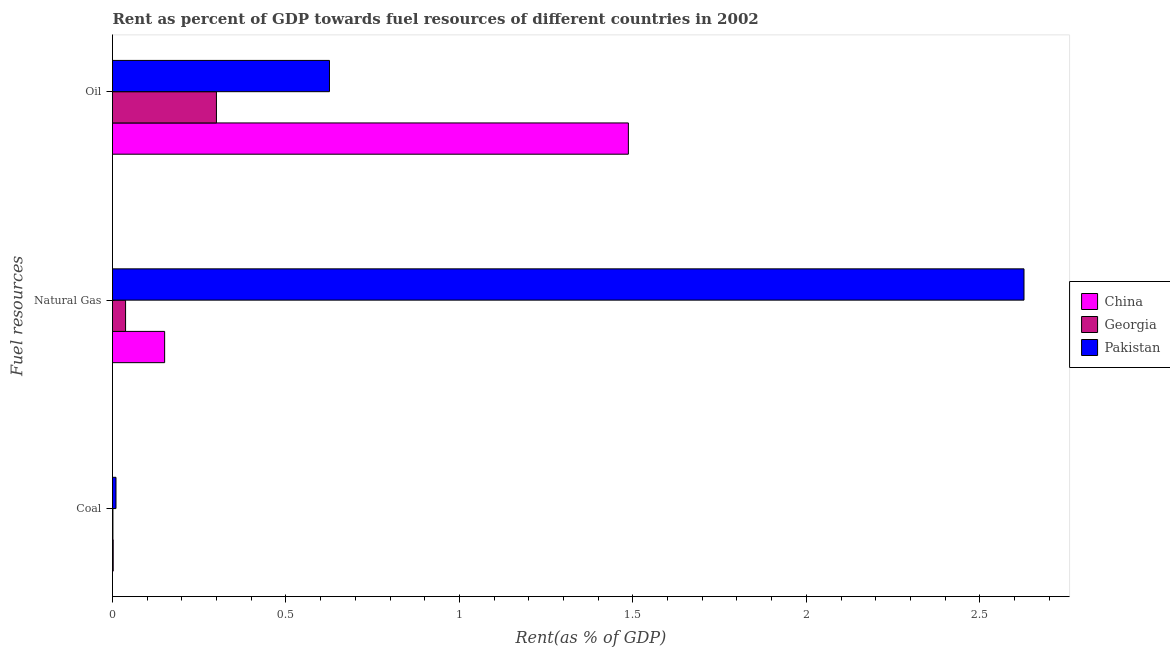How many groups of bars are there?
Your answer should be very brief. 3. Are the number of bars per tick equal to the number of legend labels?
Provide a short and direct response. Yes. Are the number of bars on each tick of the Y-axis equal?
Your answer should be very brief. Yes. How many bars are there on the 3rd tick from the top?
Your answer should be very brief. 3. What is the label of the 2nd group of bars from the top?
Offer a terse response. Natural Gas. What is the rent towards oil in Pakistan?
Offer a terse response. 0.63. Across all countries, what is the maximum rent towards natural gas?
Your response must be concise. 2.63. Across all countries, what is the minimum rent towards coal?
Provide a short and direct response. 0. In which country was the rent towards coal minimum?
Your response must be concise. Georgia. What is the total rent towards natural gas in the graph?
Offer a terse response. 2.82. What is the difference between the rent towards oil in Pakistan and that in Georgia?
Provide a short and direct response. 0.33. What is the difference between the rent towards natural gas in Georgia and the rent towards coal in China?
Offer a very short reply. 0.04. What is the average rent towards natural gas per country?
Keep it short and to the point. 0.94. What is the difference between the rent towards natural gas and rent towards coal in China?
Offer a very short reply. 0.15. In how many countries, is the rent towards oil greater than 1.4 %?
Offer a very short reply. 1. What is the ratio of the rent towards oil in Pakistan to that in China?
Give a very brief answer. 0.42. What is the difference between the highest and the second highest rent towards natural gas?
Your response must be concise. 2.48. What is the difference between the highest and the lowest rent towards oil?
Make the answer very short. 1.19. In how many countries, is the rent towards coal greater than the average rent towards coal taken over all countries?
Make the answer very short. 1. What does the 2nd bar from the bottom in Oil represents?
Your answer should be compact. Georgia. How many bars are there?
Provide a succinct answer. 9. What is the difference between two consecutive major ticks on the X-axis?
Your answer should be compact. 0.5. Where does the legend appear in the graph?
Offer a very short reply. Center right. What is the title of the graph?
Keep it short and to the point. Rent as percent of GDP towards fuel resources of different countries in 2002. What is the label or title of the X-axis?
Ensure brevity in your answer.  Rent(as % of GDP). What is the label or title of the Y-axis?
Ensure brevity in your answer.  Fuel resources. What is the Rent(as % of GDP) in China in Coal?
Provide a short and direct response. 0. What is the Rent(as % of GDP) of Georgia in Coal?
Give a very brief answer. 0. What is the Rent(as % of GDP) of Pakistan in Coal?
Offer a very short reply. 0.01. What is the Rent(as % of GDP) in China in Natural Gas?
Offer a very short reply. 0.15. What is the Rent(as % of GDP) of Georgia in Natural Gas?
Your response must be concise. 0.04. What is the Rent(as % of GDP) of Pakistan in Natural Gas?
Provide a short and direct response. 2.63. What is the Rent(as % of GDP) of China in Oil?
Your answer should be very brief. 1.49. What is the Rent(as % of GDP) of Georgia in Oil?
Make the answer very short. 0.3. What is the Rent(as % of GDP) of Pakistan in Oil?
Keep it short and to the point. 0.63. Across all Fuel resources, what is the maximum Rent(as % of GDP) of China?
Make the answer very short. 1.49. Across all Fuel resources, what is the maximum Rent(as % of GDP) in Georgia?
Your answer should be compact. 0.3. Across all Fuel resources, what is the maximum Rent(as % of GDP) in Pakistan?
Your answer should be very brief. 2.63. Across all Fuel resources, what is the minimum Rent(as % of GDP) in China?
Your answer should be compact. 0. Across all Fuel resources, what is the minimum Rent(as % of GDP) in Georgia?
Provide a succinct answer. 0. Across all Fuel resources, what is the minimum Rent(as % of GDP) in Pakistan?
Offer a very short reply. 0.01. What is the total Rent(as % of GDP) in China in the graph?
Provide a succinct answer. 1.64. What is the total Rent(as % of GDP) of Georgia in the graph?
Offer a very short reply. 0.34. What is the total Rent(as % of GDP) of Pakistan in the graph?
Offer a very short reply. 3.26. What is the difference between the Rent(as % of GDP) in China in Coal and that in Natural Gas?
Your answer should be compact. -0.15. What is the difference between the Rent(as % of GDP) of Georgia in Coal and that in Natural Gas?
Give a very brief answer. -0.04. What is the difference between the Rent(as % of GDP) in Pakistan in Coal and that in Natural Gas?
Ensure brevity in your answer.  -2.62. What is the difference between the Rent(as % of GDP) in China in Coal and that in Oil?
Offer a very short reply. -1.48. What is the difference between the Rent(as % of GDP) of Georgia in Coal and that in Oil?
Offer a very short reply. -0.3. What is the difference between the Rent(as % of GDP) of Pakistan in Coal and that in Oil?
Your answer should be compact. -0.62. What is the difference between the Rent(as % of GDP) in China in Natural Gas and that in Oil?
Give a very brief answer. -1.34. What is the difference between the Rent(as % of GDP) of Georgia in Natural Gas and that in Oil?
Keep it short and to the point. -0.26. What is the difference between the Rent(as % of GDP) in Pakistan in Natural Gas and that in Oil?
Ensure brevity in your answer.  2. What is the difference between the Rent(as % of GDP) in China in Coal and the Rent(as % of GDP) in Georgia in Natural Gas?
Your response must be concise. -0.04. What is the difference between the Rent(as % of GDP) in China in Coal and the Rent(as % of GDP) in Pakistan in Natural Gas?
Provide a short and direct response. -2.63. What is the difference between the Rent(as % of GDP) of Georgia in Coal and the Rent(as % of GDP) of Pakistan in Natural Gas?
Make the answer very short. -2.63. What is the difference between the Rent(as % of GDP) of China in Coal and the Rent(as % of GDP) of Georgia in Oil?
Make the answer very short. -0.3. What is the difference between the Rent(as % of GDP) of China in Coal and the Rent(as % of GDP) of Pakistan in Oil?
Offer a terse response. -0.62. What is the difference between the Rent(as % of GDP) of Georgia in Coal and the Rent(as % of GDP) of Pakistan in Oil?
Make the answer very short. -0.62. What is the difference between the Rent(as % of GDP) of China in Natural Gas and the Rent(as % of GDP) of Georgia in Oil?
Offer a terse response. -0.15. What is the difference between the Rent(as % of GDP) in China in Natural Gas and the Rent(as % of GDP) in Pakistan in Oil?
Provide a short and direct response. -0.48. What is the difference between the Rent(as % of GDP) in Georgia in Natural Gas and the Rent(as % of GDP) in Pakistan in Oil?
Make the answer very short. -0.59. What is the average Rent(as % of GDP) in China per Fuel resources?
Keep it short and to the point. 0.55. What is the average Rent(as % of GDP) of Georgia per Fuel resources?
Keep it short and to the point. 0.11. What is the average Rent(as % of GDP) of Pakistan per Fuel resources?
Offer a terse response. 1.09. What is the difference between the Rent(as % of GDP) of China and Rent(as % of GDP) of Georgia in Coal?
Make the answer very short. 0. What is the difference between the Rent(as % of GDP) of China and Rent(as % of GDP) of Pakistan in Coal?
Keep it short and to the point. -0.01. What is the difference between the Rent(as % of GDP) of Georgia and Rent(as % of GDP) of Pakistan in Coal?
Offer a very short reply. -0.01. What is the difference between the Rent(as % of GDP) in China and Rent(as % of GDP) in Georgia in Natural Gas?
Offer a terse response. 0.11. What is the difference between the Rent(as % of GDP) in China and Rent(as % of GDP) in Pakistan in Natural Gas?
Provide a short and direct response. -2.48. What is the difference between the Rent(as % of GDP) in Georgia and Rent(as % of GDP) in Pakistan in Natural Gas?
Your answer should be compact. -2.59. What is the difference between the Rent(as % of GDP) in China and Rent(as % of GDP) in Georgia in Oil?
Your answer should be compact. 1.19. What is the difference between the Rent(as % of GDP) of China and Rent(as % of GDP) of Pakistan in Oil?
Offer a terse response. 0.86. What is the difference between the Rent(as % of GDP) in Georgia and Rent(as % of GDP) in Pakistan in Oil?
Keep it short and to the point. -0.33. What is the ratio of the Rent(as % of GDP) of China in Coal to that in Natural Gas?
Offer a terse response. 0.01. What is the ratio of the Rent(as % of GDP) of Georgia in Coal to that in Natural Gas?
Offer a very short reply. 0.03. What is the ratio of the Rent(as % of GDP) of Pakistan in Coal to that in Natural Gas?
Your answer should be compact. 0. What is the ratio of the Rent(as % of GDP) in China in Coal to that in Oil?
Keep it short and to the point. 0. What is the ratio of the Rent(as % of GDP) of Georgia in Coal to that in Oil?
Your answer should be very brief. 0. What is the ratio of the Rent(as % of GDP) of Pakistan in Coal to that in Oil?
Offer a very short reply. 0.02. What is the ratio of the Rent(as % of GDP) of China in Natural Gas to that in Oil?
Offer a very short reply. 0.1. What is the ratio of the Rent(as % of GDP) in Georgia in Natural Gas to that in Oil?
Keep it short and to the point. 0.13. What is the ratio of the Rent(as % of GDP) in Pakistan in Natural Gas to that in Oil?
Make the answer very short. 4.2. What is the difference between the highest and the second highest Rent(as % of GDP) in China?
Keep it short and to the point. 1.34. What is the difference between the highest and the second highest Rent(as % of GDP) of Georgia?
Provide a short and direct response. 0.26. What is the difference between the highest and the second highest Rent(as % of GDP) of Pakistan?
Make the answer very short. 2. What is the difference between the highest and the lowest Rent(as % of GDP) of China?
Your answer should be very brief. 1.48. What is the difference between the highest and the lowest Rent(as % of GDP) of Georgia?
Your response must be concise. 0.3. What is the difference between the highest and the lowest Rent(as % of GDP) in Pakistan?
Your response must be concise. 2.62. 